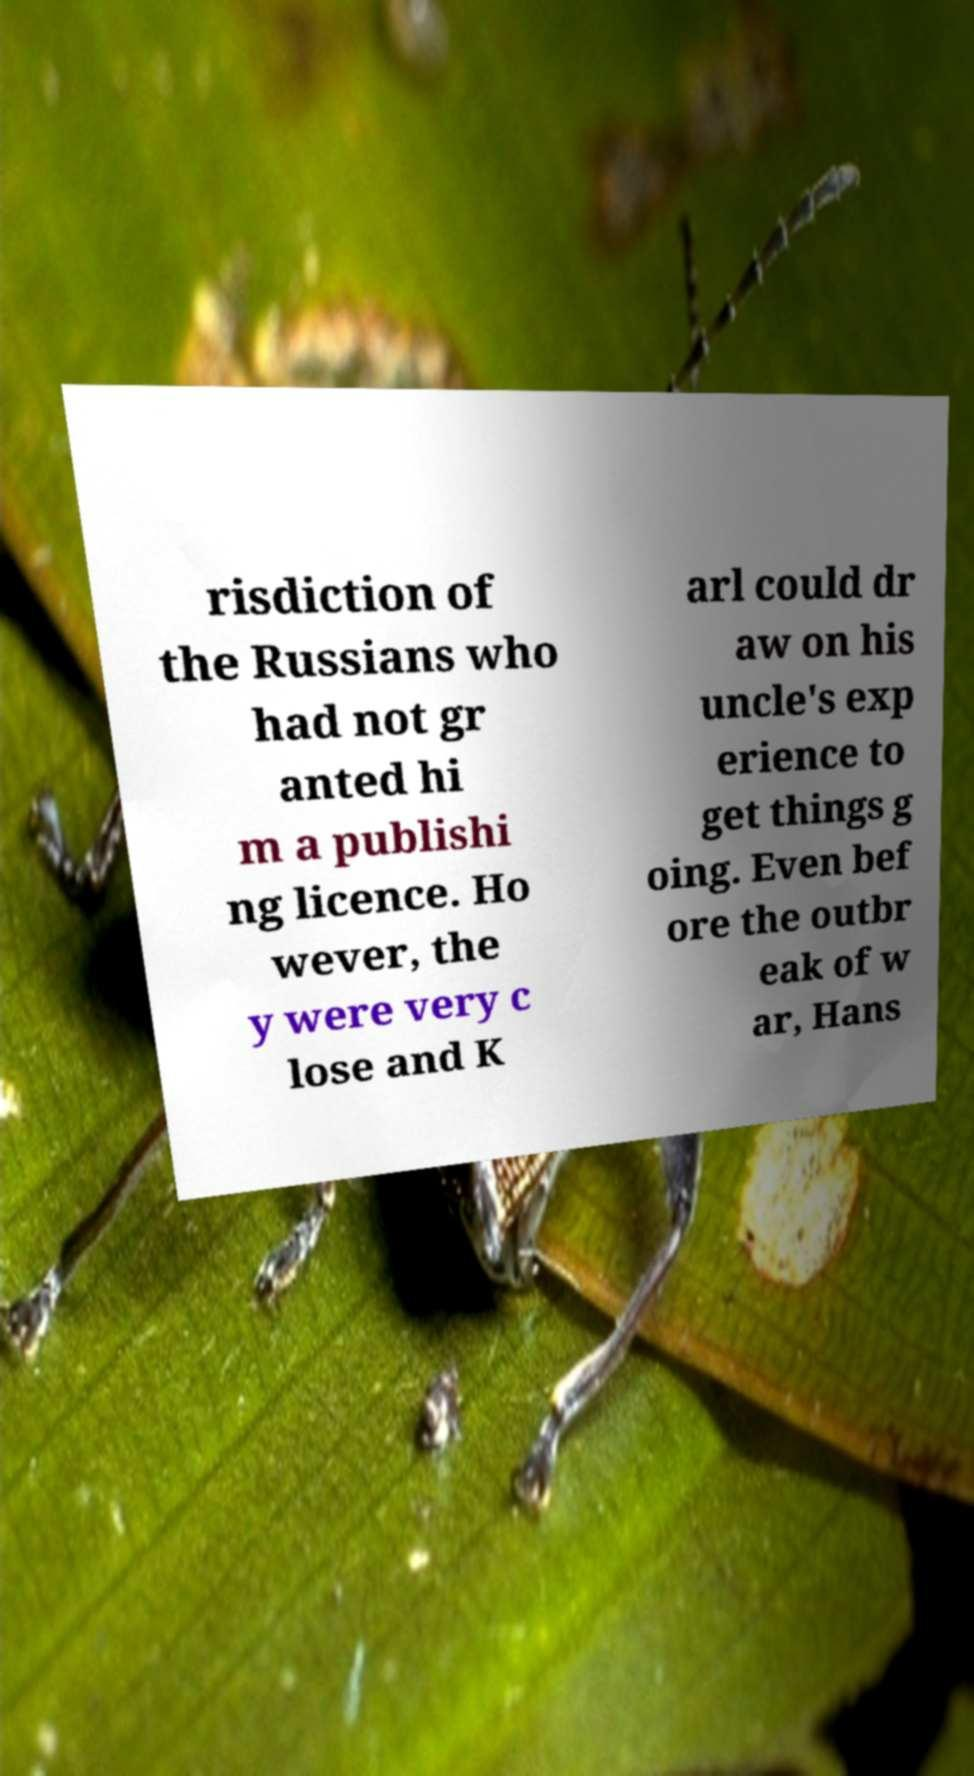There's text embedded in this image that I need extracted. Can you transcribe it verbatim? risdiction of the Russians who had not gr anted hi m a publishi ng licence. Ho wever, the y were very c lose and K arl could dr aw on his uncle's exp erience to get things g oing. Even bef ore the outbr eak of w ar, Hans 